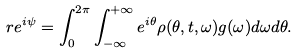Convert formula to latex. <formula><loc_0><loc_0><loc_500><loc_500>r e ^ { i \psi } = \int _ { 0 } ^ { 2 \pi } \int _ { - \infty } ^ { + \infty } e ^ { i \theta } \rho ( \theta , t , \omega ) g ( \omega ) d \omega d \theta .</formula> 